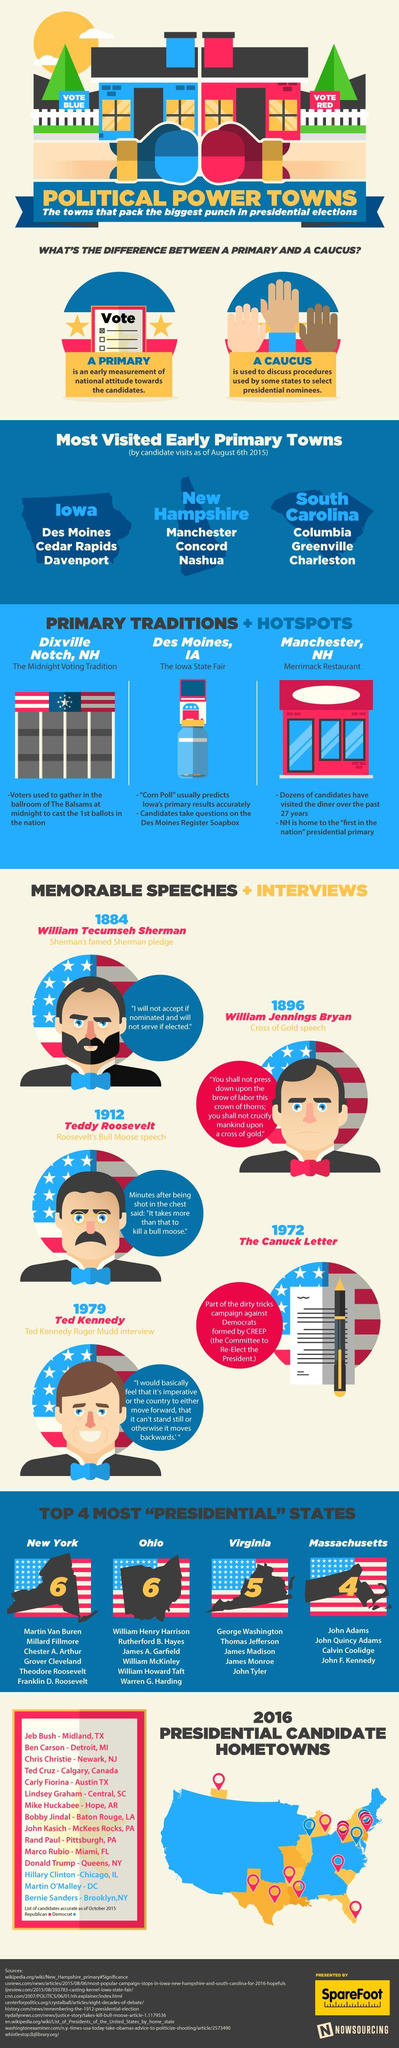Which states had the most number of President elects ?
Answer the question with a short phrase. New York, Ohio Which state does the Columbia, Greenville and Charleston cities belong? South Carolina Which state has the midnight voting tradition, New Hampshire, Iowa, or South Carolina? New Hampshire 